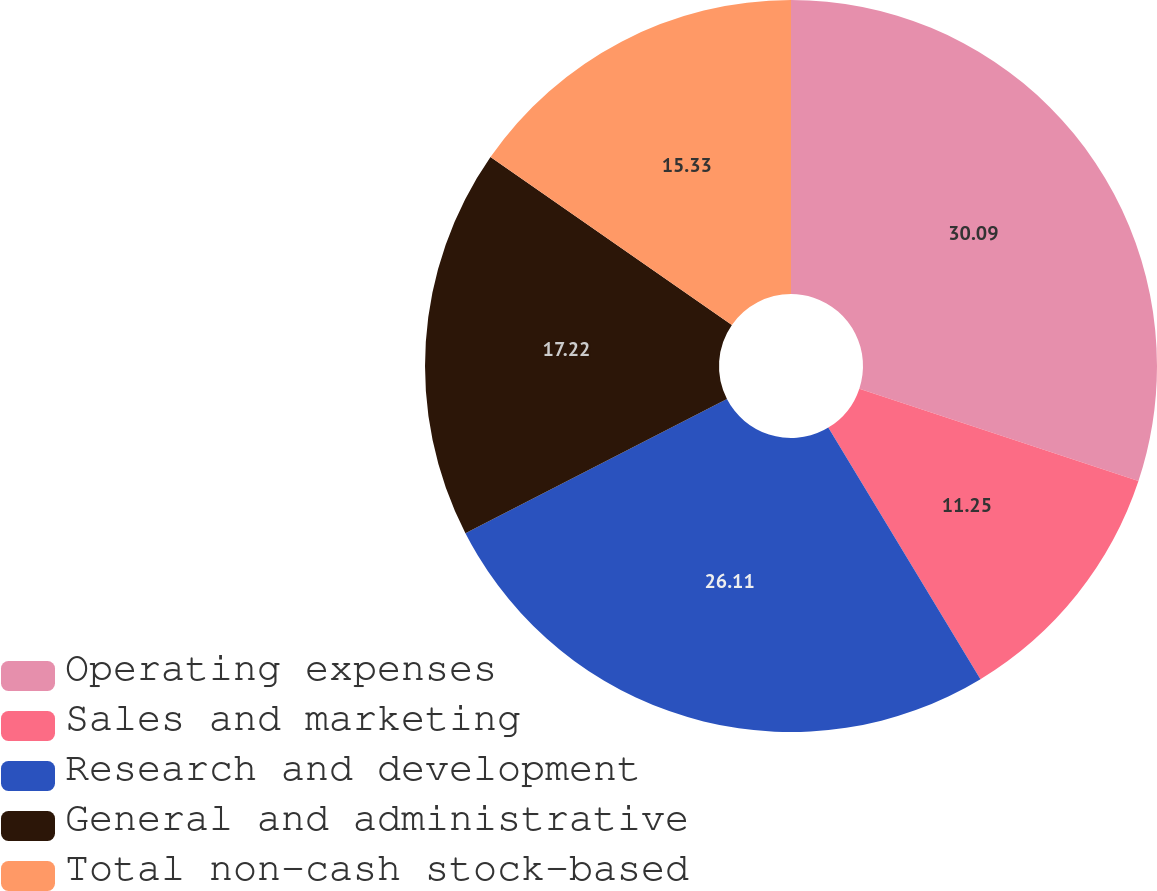Convert chart to OTSL. <chart><loc_0><loc_0><loc_500><loc_500><pie_chart><fcel>Operating expenses<fcel>Sales and marketing<fcel>Research and development<fcel>General and administrative<fcel>Total non-cash stock-based<nl><fcel>30.09%<fcel>11.25%<fcel>26.11%<fcel>17.22%<fcel>15.33%<nl></chart> 